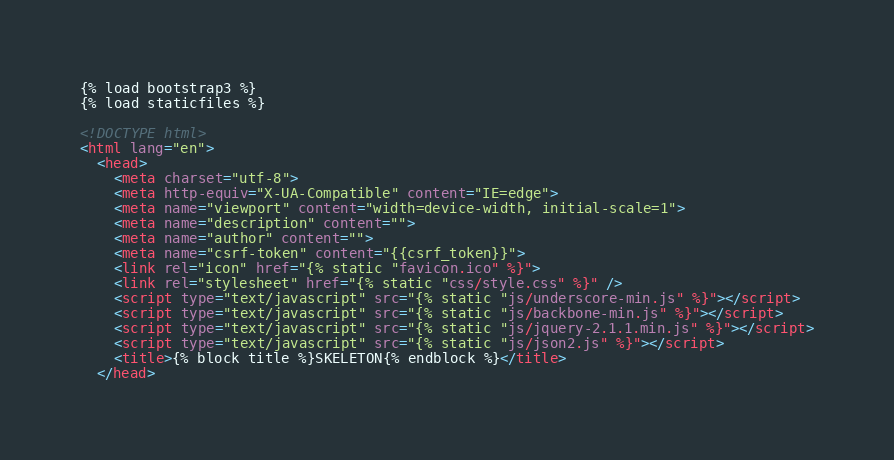Convert code to text. <code><loc_0><loc_0><loc_500><loc_500><_HTML_>{% load bootstrap3 %}
{% load staticfiles %}

<!DOCTYPE html>
<html lang="en">
  <head>
    <meta charset="utf-8">
    <meta http-equiv="X-UA-Compatible" content="IE=edge">
    <meta name="viewport" content="width=device-width, initial-scale=1">
    <meta name="description" content="">
    <meta name="author" content="">
    <meta name="csrf-token" content="{{csrf_token}}">
    <link rel="icon" href="{% static "favicon.ico" %}">
    <link rel="stylesheet" href="{% static "css/style.css" %}" />
    <script type="text/javascript" src="{% static "js/underscore-min.js" %}"></script>
    <script type="text/javascript" src="{% static "js/backbone-min.js" %}"></script>
    <script type="text/javascript" src="{% static "js/jquery-2.1.1.min.js" %}"></script>
    <script type="text/javascript" src="{% static "js/json2.js" %}"></script>
    <title>{% block title %}SKELETON{% endblock %}</title>
  </head>
</code> 